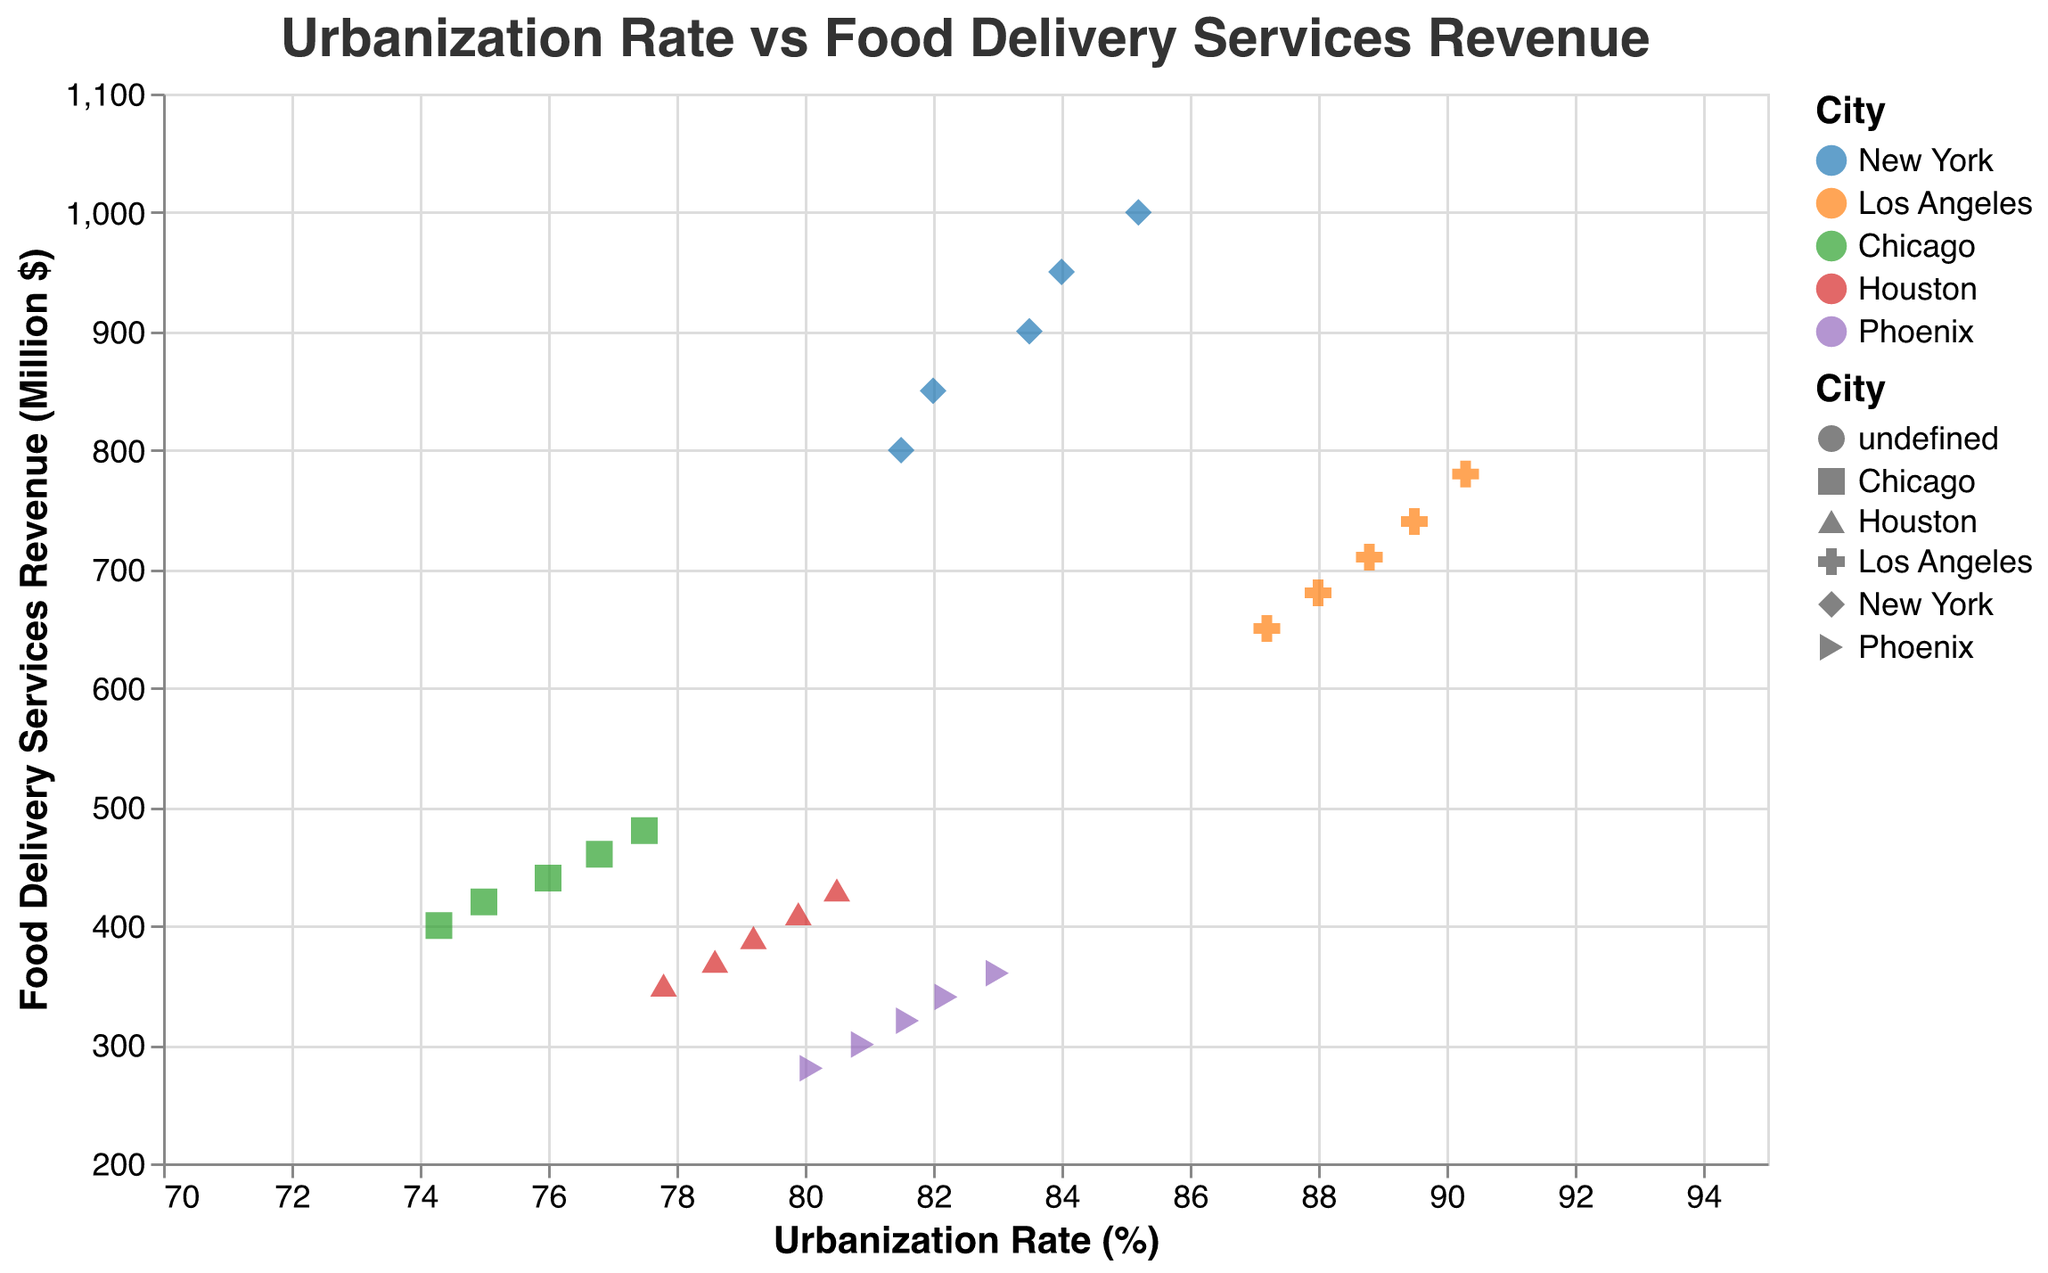What's the title of the figure? The title is at the top of the figure, which reads "Urbanization Rate vs Food Delivery Services Revenue".
Answer: Urbanization Rate vs Food Delivery Services Revenue What are the units of the x-axis? The x-axis is labeled "Urbanization Rate (%)", indicating it is measured in percentage.
Answer: Percentage How many cities are represented in the plot? The legend shows five different colors and shapes, each representing one city: New York, Los Angeles, Chicago, Houston, and Phoenix.
Answer: Five Which city had the highest food delivery services revenue in 2020? By referring to the tooltip information for the year 2020, the data point for New York indicates the highest revenue at 1000 million dollars.
Answer: New York What is the trend shown by the trend line? The trend line is gray and shows a positive slope, indicating that as the urbanization rate increases, the food delivery services revenue also increases.
Answer: Positive correlation What's the difference in food delivery services revenue for New York between 2016 and 2020? The tooltip shows New York's revenue as 800 million in 2016 and 1000 million in 2020. The difference is 1000 - 800.
Answer: 200 million Which city shows the least variation in urbanization rates over the years? By examining the positions of the points across years for each city, Phoenix shows the least variation in urbanization rates as points are clustered closely along the x-axis.
Answer: Phoenix Between which two cities is the urbanization rate highest in 2019? Using the tooltip for the year 2019, Los Angeles has an urbanization rate of 89.5%, and Phoenix has 82.2%. Los Angeles has the highest urbanization rate.
Answer: Los Angeles and Phoenix Which city saw the greatest increase in revenue from food delivery services from 2016 to 2020? By comparing the tooltip values for each city's revenue in 2016 and 2020, New York saw an increase from 800 million to 1000 million, which is the highest increase.
Answer: New York What is the average urbanization rate of Los Angeles in the dataset? The urbanization rates for Los Angeles from 2016 to 2020 are 87.2, 88.0, 88.8, 89.5, and 90.3. Summing them gives 443.8, and the average is 443.8/5.
Answer: 88.76 Which data points fall below the trend line? Points for Houston and Phoenix fall below the trend line, as their food delivery revenues are relatively low for their urbanization rates.
Answer: Houston and Phoenix 